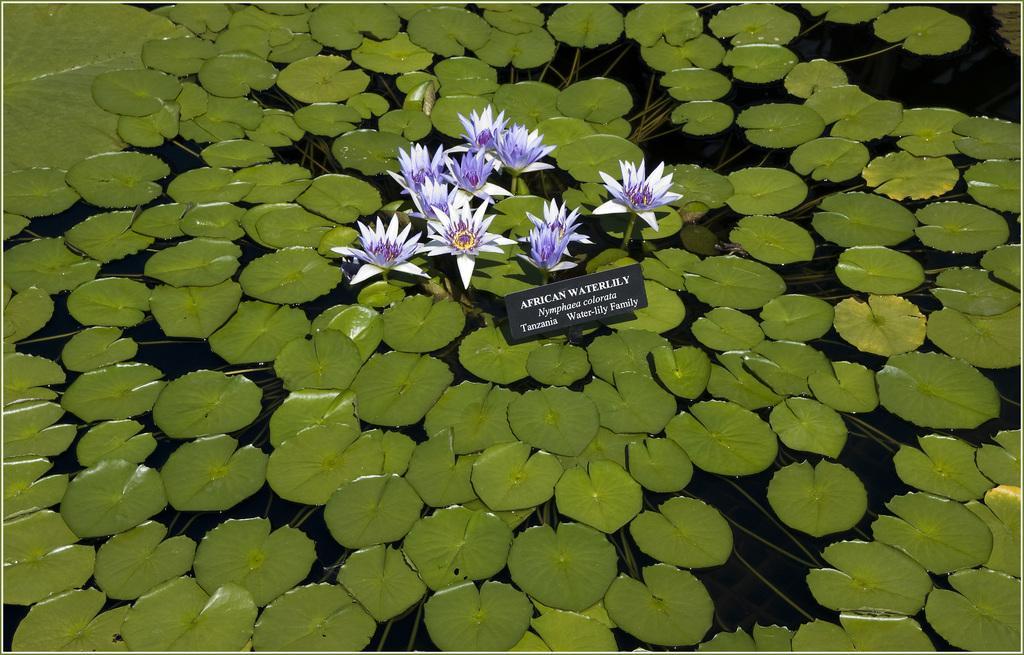Describe this image in one or two sentences. In this image I can see flowers in white and purple color, a board in black color and few leaves in green color on the water. 